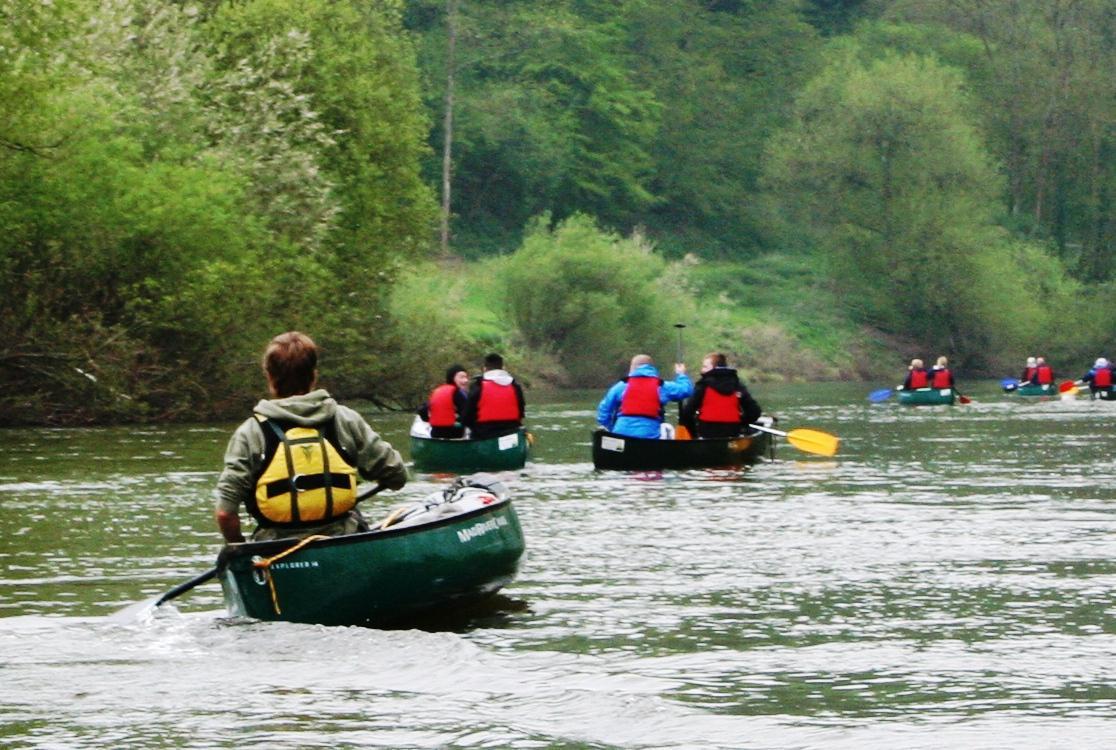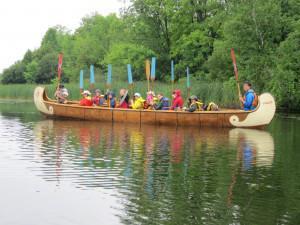The first image is the image on the left, the second image is the image on the right. Given the left and right images, does the statement "There is more than one canoe in each image." hold true? Answer yes or no. No. The first image is the image on the left, the second image is the image on the right. Examine the images to the left and right. Is the description "The right image features multiple canoes heading forward at a right angle that are not aligned side-by-side." accurate? Answer yes or no. No. 